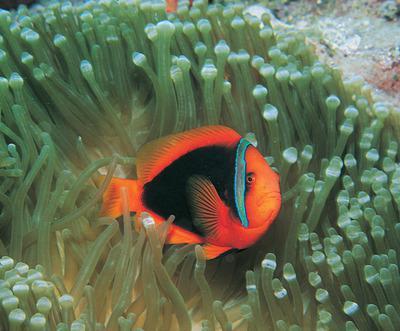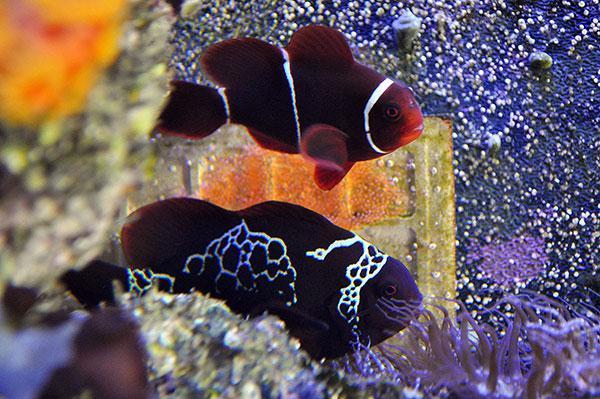The first image is the image on the left, the second image is the image on the right. Analyze the images presented: Is the assertion "One image shows a single orange-yellow fish with two white stripes above anemone, and no image contains fish that are not yellowish." valid? Answer yes or no. No. The first image is the image on the left, the second image is the image on the right. Evaluate the accuracy of this statement regarding the images: "There is exactly one fish in both images.". Is it true? Answer yes or no. No. 